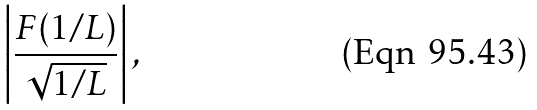Convert formula to latex. <formula><loc_0><loc_0><loc_500><loc_500>\left | \frac { F ( 1 / L ) } { \sqrt { 1 / L } } \right | ,</formula> 